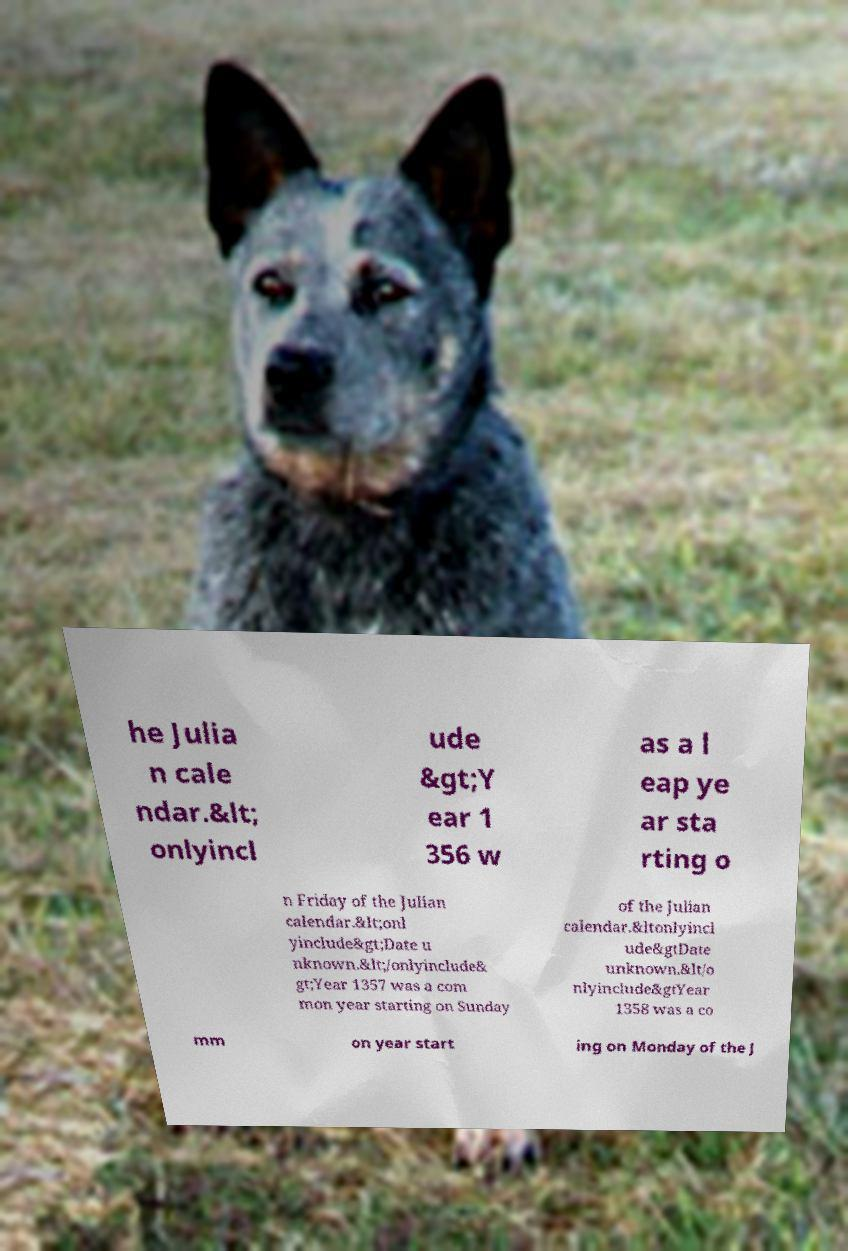What messages or text are displayed in this image? I need them in a readable, typed format. he Julia n cale ndar.&lt; onlyincl ude &gt;Y ear 1 356 w as a l eap ye ar sta rting o n Friday of the Julian calendar.&lt;onl yinclude&gt;Date u nknown.&lt;/onlyinclude& gt;Year 1357 was a com mon year starting on Sunday of the Julian calendar.&ltonlyincl ude&gtDate unknown.&lt/o nlyinclude&gtYear 1358 was a co mm on year start ing on Monday of the J 